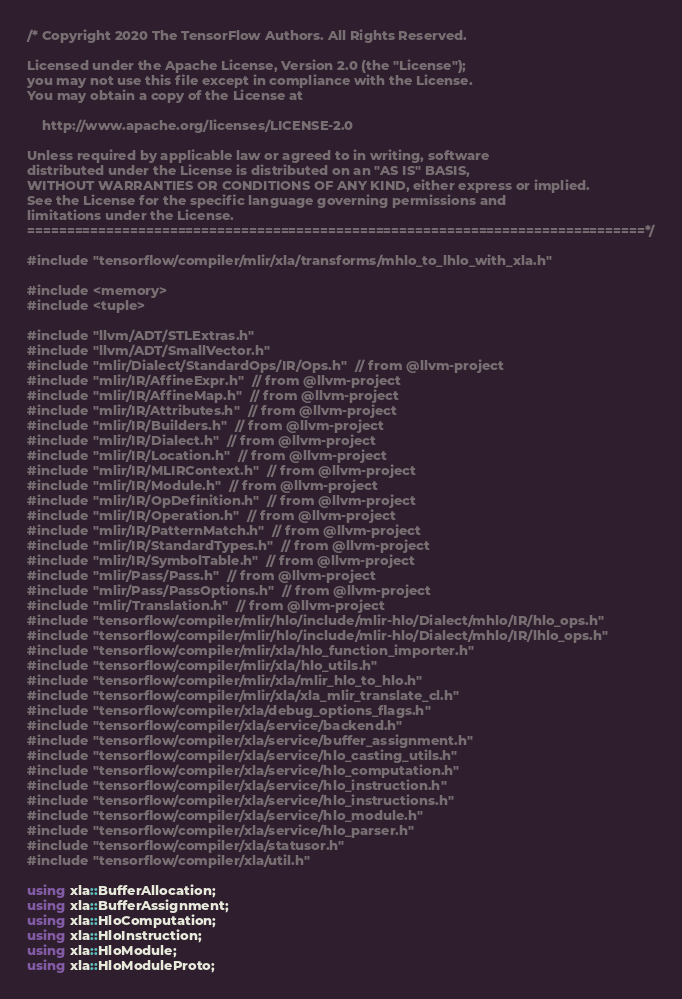Convert code to text. <code><loc_0><loc_0><loc_500><loc_500><_C++_>/* Copyright 2020 The TensorFlow Authors. All Rights Reserved.

Licensed under the Apache License, Version 2.0 (the "License");
you may not use this file except in compliance with the License.
You may obtain a copy of the License at

    http://www.apache.org/licenses/LICENSE-2.0

Unless required by applicable law or agreed to in writing, software
distributed under the License is distributed on an "AS IS" BASIS,
WITHOUT WARRANTIES OR CONDITIONS OF ANY KIND, either express or implied.
See the License for the specific language governing permissions and
limitations under the License.
==============================================================================*/

#include "tensorflow/compiler/mlir/xla/transforms/mhlo_to_lhlo_with_xla.h"

#include <memory>
#include <tuple>

#include "llvm/ADT/STLExtras.h"
#include "llvm/ADT/SmallVector.h"
#include "mlir/Dialect/StandardOps/IR/Ops.h"  // from @llvm-project
#include "mlir/IR/AffineExpr.h"  // from @llvm-project
#include "mlir/IR/AffineMap.h"  // from @llvm-project
#include "mlir/IR/Attributes.h"  // from @llvm-project
#include "mlir/IR/Builders.h"  // from @llvm-project
#include "mlir/IR/Dialect.h"  // from @llvm-project
#include "mlir/IR/Location.h"  // from @llvm-project
#include "mlir/IR/MLIRContext.h"  // from @llvm-project
#include "mlir/IR/Module.h"  // from @llvm-project
#include "mlir/IR/OpDefinition.h"  // from @llvm-project
#include "mlir/IR/Operation.h"  // from @llvm-project
#include "mlir/IR/PatternMatch.h"  // from @llvm-project
#include "mlir/IR/StandardTypes.h"  // from @llvm-project
#include "mlir/IR/SymbolTable.h"  // from @llvm-project
#include "mlir/Pass/Pass.h"  // from @llvm-project
#include "mlir/Pass/PassOptions.h"  // from @llvm-project
#include "mlir/Translation.h"  // from @llvm-project
#include "tensorflow/compiler/mlir/hlo/include/mlir-hlo/Dialect/mhlo/IR/hlo_ops.h"
#include "tensorflow/compiler/mlir/hlo/include/mlir-hlo/Dialect/mhlo/IR/lhlo_ops.h"
#include "tensorflow/compiler/mlir/xla/hlo_function_importer.h"
#include "tensorflow/compiler/mlir/xla/hlo_utils.h"
#include "tensorflow/compiler/mlir/xla/mlir_hlo_to_hlo.h"
#include "tensorflow/compiler/mlir/xla/xla_mlir_translate_cl.h"
#include "tensorflow/compiler/xla/debug_options_flags.h"
#include "tensorflow/compiler/xla/service/backend.h"
#include "tensorflow/compiler/xla/service/buffer_assignment.h"
#include "tensorflow/compiler/xla/service/hlo_casting_utils.h"
#include "tensorflow/compiler/xla/service/hlo_computation.h"
#include "tensorflow/compiler/xla/service/hlo_instruction.h"
#include "tensorflow/compiler/xla/service/hlo_instructions.h"
#include "tensorflow/compiler/xla/service/hlo_module.h"
#include "tensorflow/compiler/xla/service/hlo_parser.h"
#include "tensorflow/compiler/xla/statusor.h"
#include "tensorflow/compiler/xla/util.h"

using xla::BufferAllocation;
using xla::BufferAssignment;
using xla::HloComputation;
using xla::HloInstruction;
using xla::HloModule;
using xla::HloModuleProto;</code> 